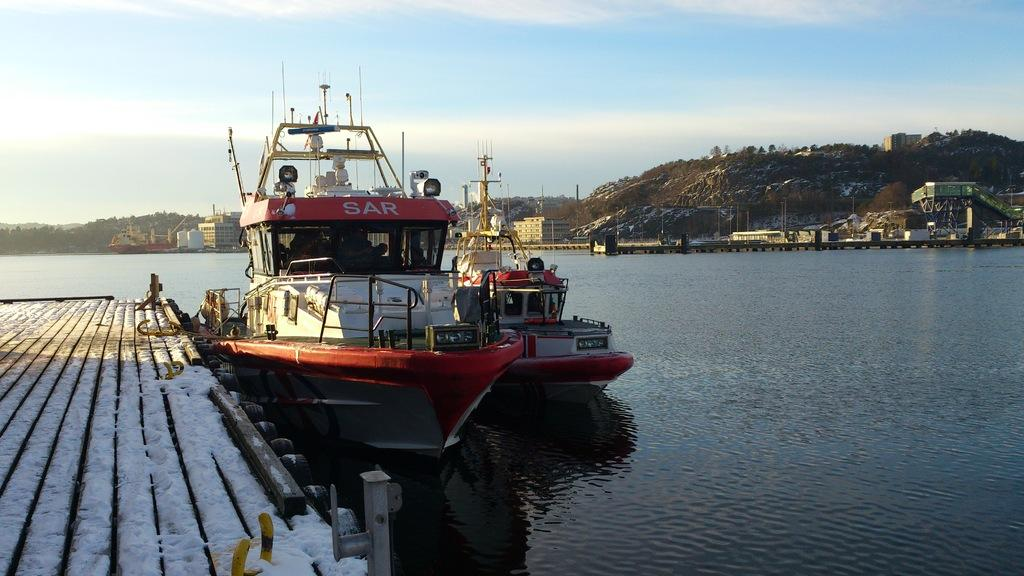<image>
Write a terse but informative summary of the picture. A red boat with SAR written on it sits at the dick 